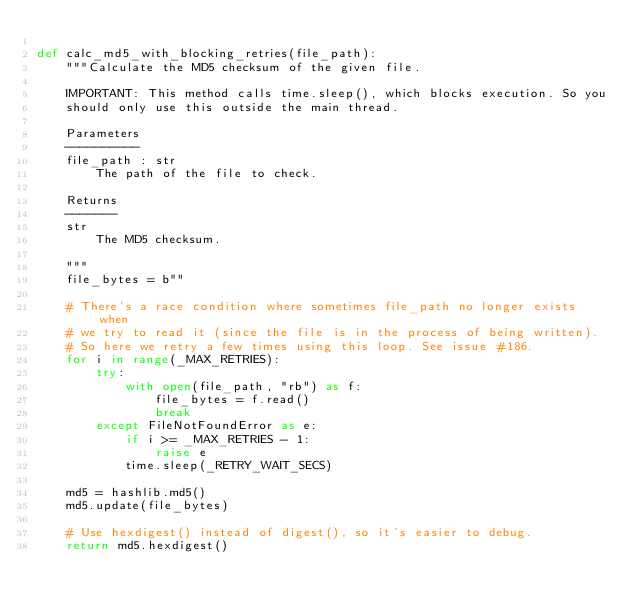<code> <loc_0><loc_0><loc_500><loc_500><_Python_>
def calc_md5_with_blocking_retries(file_path):
    """Calculate the MD5 checksum of the given file.

    IMPORTANT: This method calls time.sleep(), which blocks execution. So you
    should only use this outside the main thread.

    Parameters
    ----------
    file_path : str
        The path of the file to check.

    Returns
    -------
    str
        The MD5 checksum.

    """
    file_bytes = b""

    # There's a race condition where sometimes file_path no longer exists when
    # we try to read it (since the file is in the process of being written).
    # So here we retry a few times using this loop. See issue #186.
    for i in range(_MAX_RETRIES):
        try:
            with open(file_path, "rb") as f:
                file_bytes = f.read()
                break
        except FileNotFoundError as e:
            if i >= _MAX_RETRIES - 1:
                raise e
            time.sleep(_RETRY_WAIT_SECS)

    md5 = hashlib.md5()
    md5.update(file_bytes)

    # Use hexdigest() instead of digest(), so it's easier to debug.
    return md5.hexdigest()
</code> 